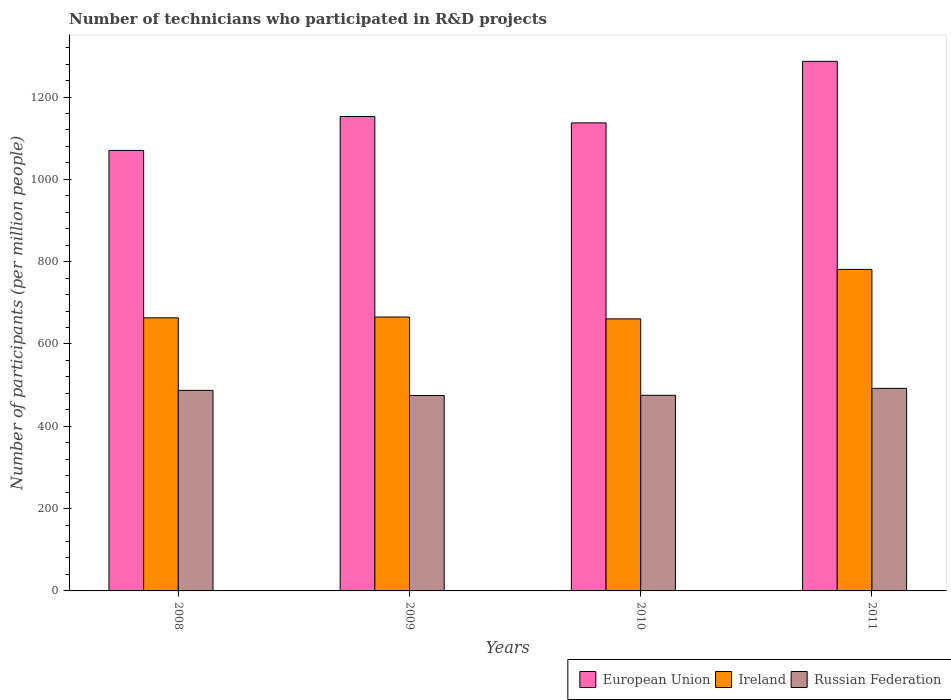How many different coloured bars are there?
Provide a short and direct response. 3. Are the number of bars per tick equal to the number of legend labels?
Provide a short and direct response. Yes. How many bars are there on the 3rd tick from the left?
Your response must be concise. 3. What is the label of the 3rd group of bars from the left?
Make the answer very short. 2010. What is the number of technicians who participated in R&D projects in Ireland in 2011?
Make the answer very short. 781.26. Across all years, what is the maximum number of technicians who participated in R&D projects in European Union?
Give a very brief answer. 1286.74. Across all years, what is the minimum number of technicians who participated in R&D projects in Ireland?
Offer a very short reply. 660.99. What is the total number of technicians who participated in R&D projects in European Union in the graph?
Offer a very short reply. 4647.01. What is the difference between the number of technicians who participated in R&D projects in Russian Federation in 2008 and that in 2010?
Ensure brevity in your answer.  12.01. What is the difference between the number of technicians who participated in R&D projects in Russian Federation in 2011 and the number of technicians who participated in R&D projects in Ireland in 2009?
Your response must be concise. -173.34. What is the average number of technicians who participated in R&D projects in European Union per year?
Offer a terse response. 1161.75. In the year 2009, what is the difference between the number of technicians who participated in R&D projects in European Union and number of technicians who participated in R&D projects in Russian Federation?
Your response must be concise. 677.96. In how many years, is the number of technicians who participated in R&D projects in Russian Federation greater than 880?
Offer a terse response. 0. What is the ratio of the number of technicians who participated in R&D projects in Ireland in 2008 to that in 2010?
Offer a very short reply. 1. Is the number of technicians who participated in R&D projects in European Union in 2008 less than that in 2009?
Provide a succinct answer. Yes. Is the difference between the number of technicians who participated in R&D projects in European Union in 2008 and 2009 greater than the difference between the number of technicians who participated in R&D projects in Russian Federation in 2008 and 2009?
Your response must be concise. No. What is the difference between the highest and the second highest number of technicians who participated in R&D projects in Russian Federation?
Provide a succinct answer. 4.91. What is the difference between the highest and the lowest number of technicians who participated in R&D projects in Russian Federation?
Offer a very short reply. 17.44. What does the 3rd bar from the left in 2011 represents?
Provide a short and direct response. Russian Federation. What does the 3rd bar from the right in 2010 represents?
Ensure brevity in your answer.  European Union. Is it the case that in every year, the sum of the number of technicians who participated in R&D projects in European Union and number of technicians who participated in R&D projects in Ireland is greater than the number of technicians who participated in R&D projects in Russian Federation?
Your response must be concise. Yes. What is the difference between two consecutive major ticks on the Y-axis?
Provide a short and direct response. 200. Are the values on the major ticks of Y-axis written in scientific E-notation?
Offer a terse response. No. How are the legend labels stacked?
Your answer should be very brief. Horizontal. What is the title of the graph?
Keep it short and to the point. Number of technicians who participated in R&D projects. What is the label or title of the Y-axis?
Provide a succinct answer. Number of participants (per million people). What is the Number of participants (per million people) in European Union in 2008?
Make the answer very short. 1070.3. What is the Number of participants (per million people) of Ireland in 2008?
Make the answer very short. 663.59. What is the Number of participants (per million people) in Russian Federation in 2008?
Keep it short and to the point. 487.31. What is the Number of participants (per million people) of European Union in 2009?
Provide a succinct answer. 1152.73. What is the Number of participants (per million people) in Ireland in 2009?
Offer a terse response. 665.55. What is the Number of participants (per million people) in Russian Federation in 2009?
Keep it short and to the point. 474.78. What is the Number of participants (per million people) of European Union in 2010?
Your answer should be very brief. 1137.23. What is the Number of participants (per million people) in Ireland in 2010?
Provide a short and direct response. 660.99. What is the Number of participants (per million people) in Russian Federation in 2010?
Offer a very short reply. 475.29. What is the Number of participants (per million people) in European Union in 2011?
Provide a succinct answer. 1286.74. What is the Number of participants (per million people) in Ireland in 2011?
Ensure brevity in your answer.  781.26. What is the Number of participants (per million people) in Russian Federation in 2011?
Give a very brief answer. 492.22. Across all years, what is the maximum Number of participants (per million people) in European Union?
Provide a succinct answer. 1286.74. Across all years, what is the maximum Number of participants (per million people) of Ireland?
Keep it short and to the point. 781.26. Across all years, what is the maximum Number of participants (per million people) in Russian Federation?
Offer a very short reply. 492.22. Across all years, what is the minimum Number of participants (per million people) of European Union?
Keep it short and to the point. 1070.3. Across all years, what is the minimum Number of participants (per million people) in Ireland?
Keep it short and to the point. 660.99. Across all years, what is the minimum Number of participants (per million people) in Russian Federation?
Keep it short and to the point. 474.78. What is the total Number of participants (per million people) of European Union in the graph?
Provide a short and direct response. 4647.01. What is the total Number of participants (per million people) in Ireland in the graph?
Give a very brief answer. 2771.4. What is the total Number of participants (per million people) of Russian Federation in the graph?
Provide a succinct answer. 1929.59. What is the difference between the Number of participants (per million people) in European Union in 2008 and that in 2009?
Give a very brief answer. -82.43. What is the difference between the Number of participants (per million people) in Ireland in 2008 and that in 2009?
Keep it short and to the point. -1.96. What is the difference between the Number of participants (per million people) in Russian Federation in 2008 and that in 2009?
Your response must be concise. 12.53. What is the difference between the Number of participants (per million people) in European Union in 2008 and that in 2010?
Provide a succinct answer. -66.92. What is the difference between the Number of participants (per million people) in Ireland in 2008 and that in 2010?
Your response must be concise. 2.61. What is the difference between the Number of participants (per million people) of Russian Federation in 2008 and that in 2010?
Your response must be concise. 12.01. What is the difference between the Number of participants (per million people) in European Union in 2008 and that in 2011?
Provide a succinct answer. -216.44. What is the difference between the Number of participants (per million people) of Ireland in 2008 and that in 2011?
Make the answer very short. -117.67. What is the difference between the Number of participants (per million people) in Russian Federation in 2008 and that in 2011?
Provide a short and direct response. -4.91. What is the difference between the Number of participants (per million people) of European Union in 2009 and that in 2010?
Ensure brevity in your answer.  15.51. What is the difference between the Number of participants (per million people) in Ireland in 2009 and that in 2010?
Provide a short and direct response. 4.57. What is the difference between the Number of participants (per million people) in Russian Federation in 2009 and that in 2010?
Your answer should be very brief. -0.52. What is the difference between the Number of participants (per million people) in European Union in 2009 and that in 2011?
Your answer should be very brief. -134.01. What is the difference between the Number of participants (per million people) in Ireland in 2009 and that in 2011?
Offer a very short reply. -115.71. What is the difference between the Number of participants (per million people) in Russian Federation in 2009 and that in 2011?
Offer a very short reply. -17.44. What is the difference between the Number of participants (per million people) of European Union in 2010 and that in 2011?
Your answer should be compact. -149.52. What is the difference between the Number of participants (per million people) of Ireland in 2010 and that in 2011?
Keep it short and to the point. -120.28. What is the difference between the Number of participants (per million people) in Russian Federation in 2010 and that in 2011?
Keep it short and to the point. -16.92. What is the difference between the Number of participants (per million people) of European Union in 2008 and the Number of participants (per million people) of Ireland in 2009?
Your answer should be very brief. 404.75. What is the difference between the Number of participants (per million people) of European Union in 2008 and the Number of participants (per million people) of Russian Federation in 2009?
Provide a short and direct response. 595.53. What is the difference between the Number of participants (per million people) of Ireland in 2008 and the Number of participants (per million people) of Russian Federation in 2009?
Your answer should be very brief. 188.82. What is the difference between the Number of participants (per million people) in European Union in 2008 and the Number of participants (per million people) in Ireland in 2010?
Keep it short and to the point. 409.32. What is the difference between the Number of participants (per million people) in European Union in 2008 and the Number of participants (per million people) in Russian Federation in 2010?
Provide a short and direct response. 595.01. What is the difference between the Number of participants (per million people) of Ireland in 2008 and the Number of participants (per million people) of Russian Federation in 2010?
Your answer should be compact. 188.3. What is the difference between the Number of participants (per million people) in European Union in 2008 and the Number of participants (per million people) in Ireland in 2011?
Keep it short and to the point. 289.04. What is the difference between the Number of participants (per million people) in European Union in 2008 and the Number of participants (per million people) in Russian Federation in 2011?
Keep it short and to the point. 578.09. What is the difference between the Number of participants (per million people) of Ireland in 2008 and the Number of participants (per million people) of Russian Federation in 2011?
Your answer should be very brief. 171.38. What is the difference between the Number of participants (per million people) of European Union in 2009 and the Number of participants (per million people) of Ireland in 2010?
Ensure brevity in your answer.  491.74. What is the difference between the Number of participants (per million people) in European Union in 2009 and the Number of participants (per million people) in Russian Federation in 2010?
Provide a short and direct response. 677.44. What is the difference between the Number of participants (per million people) in Ireland in 2009 and the Number of participants (per million people) in Russian Federation in 2010?
Give a very brief answer. 190.26. What is the difference between the Number of participants (per million people) of European Union in 2009 and the Number of participants (per million people) of Ireland in 2011?
Your response must be concise. 371.47. What is the difference between the Number of participants (per million people) of European Union in 2009 and the Number of participants (per million people) of Russian Federation in 2011?
Offer a terse response. 660.52. What is the difference between the Number of participants (per million people) in Ireland in 2009 and the Number of participants (per million people) in Russian Federation in 2011?
Ensure brevity in your answer.  173.34. What is the difference between the Number of participants (per million people) of European Union in 2010 and the Number of participants (per million people) of Ireland in 2011?
Your response must be concise. 355.96. What is the difference between the Number of participants (per million people) of European Union in 2010 and the Number of participants (per million people) of Russian Federation in 2011?
Ensure brevity in your answer.  645.01. What is the difference between the Number of participants (per million people) in Ireland in 2010 and the Number of participants (per million people) in Russian Federation in 2011?
Your response must be concise. 168.77. What is the average Number of participants (per million people) of European Union per year?
Provide a short and direct response. 1161.75. What is the average Number of participants (per million people) in Ireland per year?
Offer a terse response. 692.85. What is the average Number of participants (per million people) of Russian Federation per year?
Provide a succinct answer. 482.4. In the year 2008, what is the difference between the Number of participants (per million people) of European Union and Number of participants (per million people) of Ireland?
Give a very brief answer. 406.71. In the year 2008, what is the difference between the Number of participants (per million people) in European Union and Number of participants (per million people) in Russian Federation?
Provide a succinct answer. 583. In the year 2008, what is the difference between the Number of participants (per million people) in Ireland and Number of participants (per million people) in Russian Federation?
Ensure brevity in your answer.  176.29. In the year 2009, what is the difference between the Number of participants (per million people) in European Union and Number of participants (per million people) in Ireland?
Keep it short and to the point. 487.18. In the year 2009, what is the difference between the Number of participants (per million people) in European Union and Number of participants (per million people) in Russian Federation?
Offer a terse response. 677.96. In the year 2009, what is the difference between the Number of participants (per million people) of Ireland and Number of participants (per million people) of Russian Federation?
Offer a terse response. 190.78. In the year 2010, what is the difference between the Number of participants (per million people) of European Union and Number of participants (per million people) of Ireland?
Ensure brevity in your answer.  476.24. In the year 2010, what is the difference between the Number of participants (per million people) of European Union and Number of participants (per million people) of Russian Federation?
Your answer should be compact. 661.93. In the year 2010, what is the difference between the Number of participants (per million people) of Ireland and Number of participants (per million people) of Russian Federation?
Provide a succinct answer. 185.69. In the year 2011, what is the difference between the Number of participants (per million people) in European Union and Number of participants (per million people) in Ireland?
Provide a short and direct response. 505.48. In the year 2011, what is the difference between the Number of participants (per million people) in European Union and Number of participants (per million people) in Russian Federation?
Provide a short and direct response. 794.53. In the year 2011, what is the difference between the Number of participants (per million people) of Ireland and Number of participants (per million people) of Russian Federation?
Provide a succinct answer. 289.05. What is the ratio of the Number of participants (per million people) of European Union in 2008 to that in 2009?
Provide a short and direct response. 0.93. What is the ratio of the Number of participants (per million people) of Russian Federation in 2008 to that in 2009?
Your response must be concise. 1.03. What is the ratio of the Number of participants (per million people) in Ireland in 2008 to that in 2010?
Offer a very short reply. 1. What is the ratio of the Number of participants (per million people) in Russian Federation in 2008 to that in 2010?
Ensure brevity in your answer.  1.03. What is the ratio of the Number of participants (per million people) of European Union in 2008 to that in 2011?
Give a very brief answer. 0.83. What is the ratio of the Number of participants (per million people) in Ireland in 2008 to that in 2011?
Provide a succinct answer. 0.85. What is the ratio of the Number of participants (per million people) of European Union in 2009 to that in 2010?
Provide a short and direct response. 1.01. What is the ratio of the Number of participants (per million people) of Ireland in 2009 to that in 2010?
Make the answer very short. 1.01. What is the ratio of the Number of participants (per million people) of Russian Federation in 2009 to that in 2010?
Provide a short and direct response. 1. What is the ratio of the Number of participants (per million people) in European Union in 2009 to that in 2011?
Your answer should be compact. 0.9. What is the ratio of the Number of participants (per million people) in Ireland in 2009 to that in 2011?
Offer a terse response. 0.85. What is the ratio of the Number of participants (per million people) of Russian Federation in 2009 to that in 2011?
Offer a very short reply. 0.96. What is the ratio of the Number of participants (per million people) of European Union in 2010 to that in 2011?
Your answer should be very brief. 0.88. What is the ratio of the Number of participants (per million people) of Ireland in 2010 to that in 2011?
Ensure brevity in your answer.  0.85. What is the ratio of the Number of participants (per million people) of Russian Federation in 2010 to that in 2011?
Provide a succinct answer. 0.97. What is the difference between the highest and the second highest Number of participants (per million people) in European Union?
Provide a short and direct response. 134.01. What is the difference between the highest and the second highest Number of participants (per million people) in Ireland?
Provide a short and direct response. 115.71. What is the difference between the highest and the second highest Number of participants (per million people) of Russian Federation?
Give a very brief answer. 4.91. What is the difference between the highest and the lowest Number of participants (per million people) of European Union?
Offer a terse response. 216.44. What is the difference between the highest and the lowest Number of participants (per million people) of Ireland?
Ensure brevity in your answer.  120.28. What is the difference between the highest and the lowest Number of participants (per million people) of Russian Federation?
Keep it short and to the point. 17.44. 